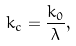Convert formula to latex. <formula><loc_0><loc_0><loc_500><loc_500>k _ { c } = \frac { k _ { 0 } } { \lambda } ,</formula> 